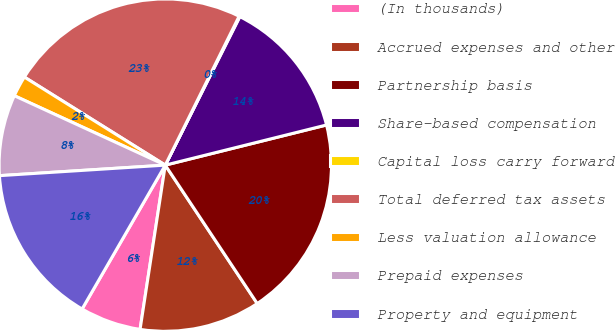Convert chart. <chart><loc_0><loc_0><loc_500><loc_500><pie_chart><fcel>(In thousands)<fcel>Accrued expenses and other<fcel>Partnership basis<fcel>Share-based compensation<fcel>Capital loss carry forward<fcel>Total deferred tax assets<fcel>Less valuation allowance<fcel>Prepaid expenses<fcel>Property and equipment<nl><fcel>5.92%<fcel>11.76%<fcel>19.55%<fcel>13.71%<fcel>0.08%<fcel>23.44%<fcel>2.03%<fcel>7.87%<fcel>15.65%<nl></chart> 